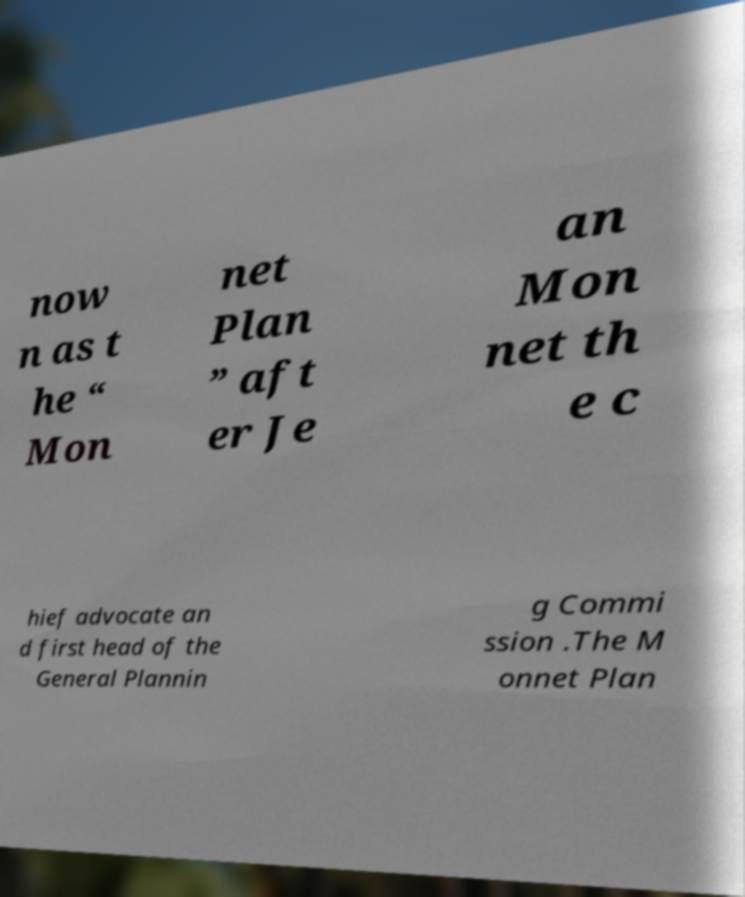What messages or text are displayed in this image? I need them in a readable, typed format. now n as t he “ Mon net Plan ” aft er Je an Mon net th e c hief advocate an d first head of the General Plannin g Commi ssion .The M onnet Plan 